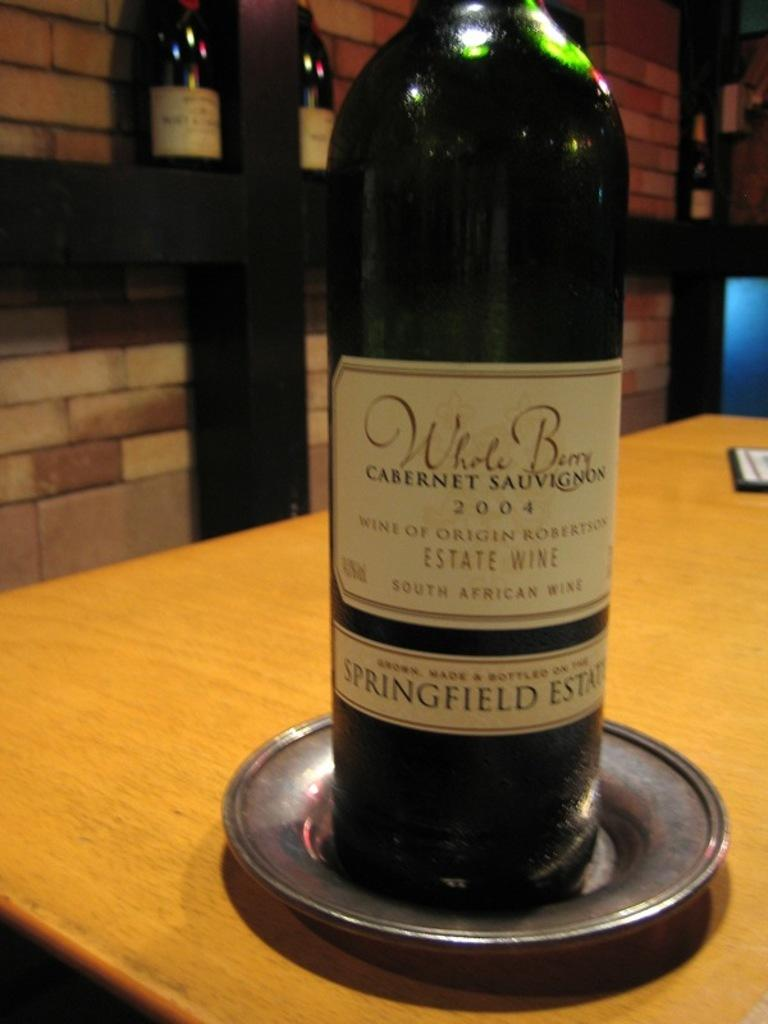<image>
Share a concise interpretation of the image provided. A bottle is labeled with the year 2004 and is on a table. 